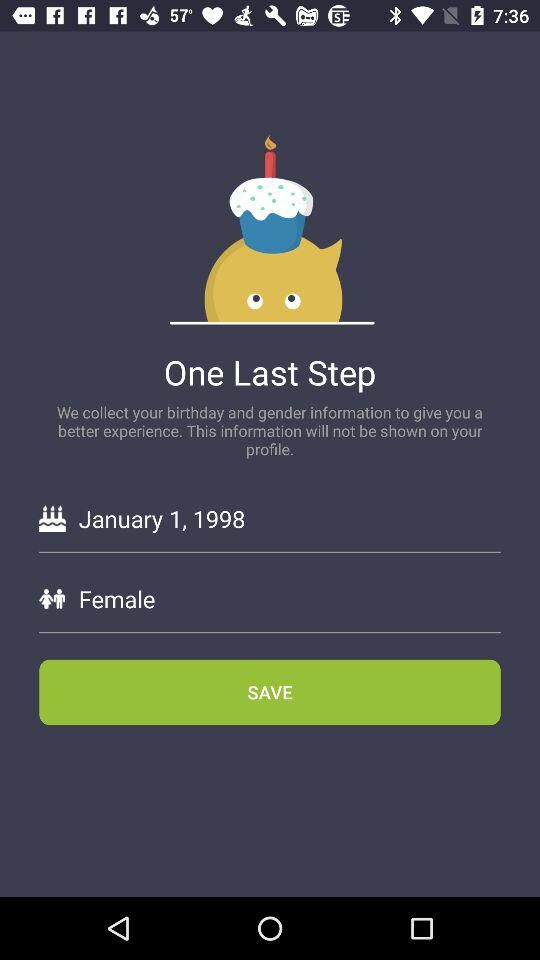How many steps are left? There is one step left. 